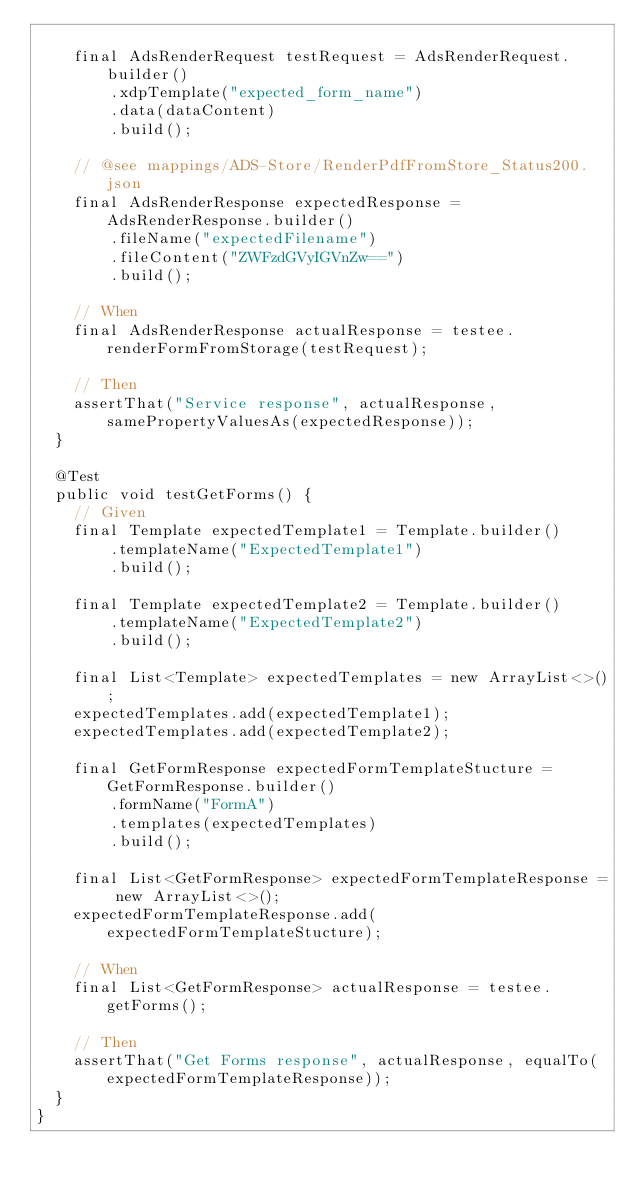Convert code to text. <code><loc_0><loc_0><loc_500><loc_500><_Java_>		
		final AdsRenderRequest testRequest = AdsRenderRequest.builder()
				.xdpTemplate("expected_form_name")
				.data(dataContent)
				.build();	
		
		// @see mappings/ADS-Store/RenderPdfFromStore_Status200.json
		final AdsRenderResponse expectedResponse = AdsRenderResponse.builder()
				.fileName("expectedFilename")
				.fileContent("ZWFzdGVyIGVnZw==")
				.build();
		
		// When
		final AdsRenderResponse actualResponse = testee.renderFormFromStorage(testRequest);

		// Then
		assertThat("Service response", actualResponse, samePropertyValuesAs(expectedResponse));
	}
	
	@Test
	public void testGetForms() {
		// Given	
		final Template expectedTemplate1 = Template.builder()
				.templateName("ExpectedTemplate1")
				.build();
		
		final Template expectedTemplate2 = Template.builder()
				.templateName("ExpectedTemplate2")
				.build();
		
		final List<Template> expectedTemplates = new ArrayList<>();
		expectedTemplates.add(expectedTemplate1);
		expectedTemplates.add(expectedTemplate2);
		
		final GetFormResponse expectedFormTemplateStucture = GetFormResponse.builder()
				.formName("FormA")
				.templates(expectedTemplates)
				.build();
		
		final List<GetFormResponse> expectedFormTemplateResponse = new ArrayList<>();
		expectedFormTemplateResponse.add(expectedFormTemplateStucture);
				
		// When
		final List<GetFormResponse> actualResponse = testee.getForms();

		// Then
		assertThat("Get Forms response", actualResponse, equalTo(expectedFormTemplateResponse));		
	}	
}

</code> 